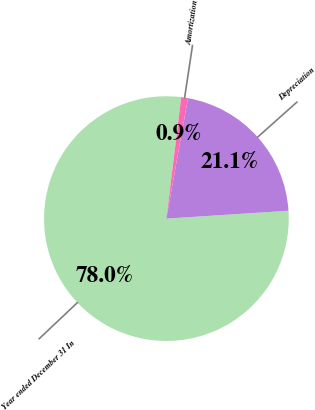Convert chart to OTSL. <chart><loc_0><loc_0><loc_500><loc_500><pie_chart><fcel>Year ended December 31 In<fcel>Depreciation<fcel>Amortization<nl><fcel>77.96%<fcel>21.15%<fcel>0.89%<nl></chart> 